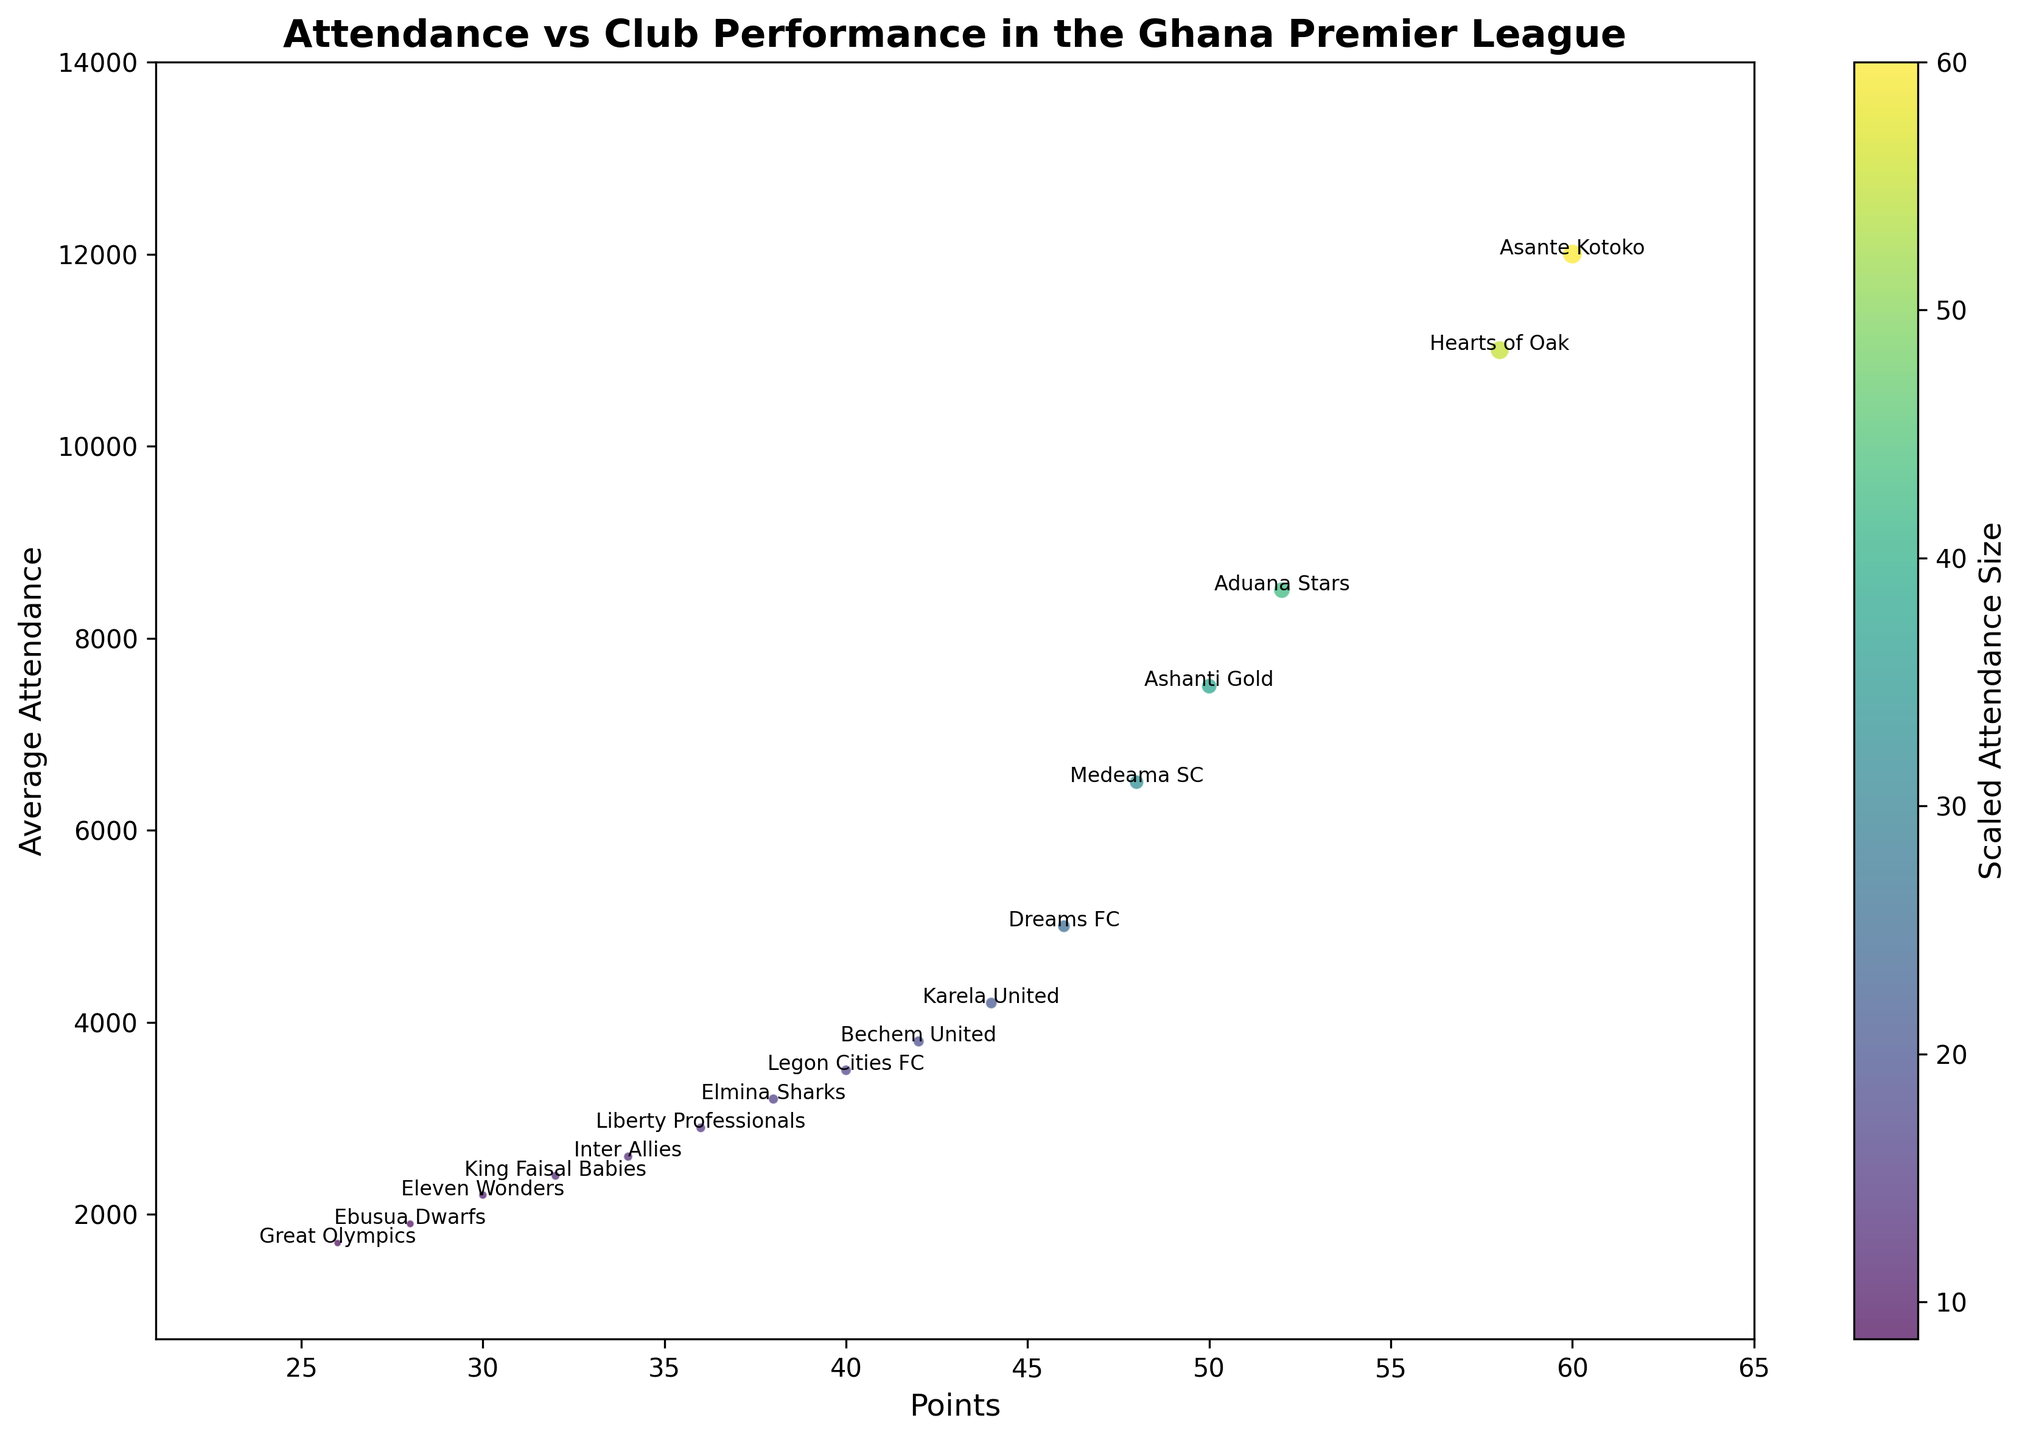What's the club with the highest attendance? The club with the highest attendance can be identified by checking the topmost point on the y-axis of the chart. The highest point corresponds to Asante Kotoko.
Answer: Asante Kotoko Which club has the lowest points? To find the club with the lowest points, look for the leftmost point on the x-axis of the chart. The leftmost point corresponds to Great Olympics.
Answer: Great Olympics How does the average attendance of Hearts of Oak compare to Aduana Stars? Look for the points labeled Hearts of Oak and Aduana Stars and compare their y-axis values. Hearts of Oak has an attendance of 11,000, which is higher than Aduana Stars' 8,500.
Answer: Hearts of Oak has higher attendance Which club has a higher performance, Medeama SC or Dreams FC? To compare performance, look at the x-axis values. Medeama SC has 48 points while Dreams FC has 46 points. This means Medeama SC has a higher performance.
Answer: Medeama SC What's the sum of attendance for Legon Cities FC and Inter Allies? Locate the attendance values for Legon Cities FC (3,500) and Inter Allies (2,600). Summing these values gives 3,500 + 2,600 = 6,100.
Answer: 6,100 Which club with an attendance over 10,000 has more points, Asante Kotoko or Hearts of Oak? Both clubs have an attendance over 10,000. Compare their points: Asante Kotoko has 60 points and Hearts of Oak has 58 points. Therefore, Asante Kotoko has more points.
Answer: Asante Kotoko What's the difference in points between Karela United and Bechem United? Check the x-axis values for Karela United (44) and Bechem United (42). The difference is 44 - 42 = 2 points.
Answer: 2 points Which club has the smallest bubble size on the chart? Bubble size is scaled by attendance. The smallest bubble will be for the club with the lowest attendance. Great Olympics, with an attendance of 1,700, is the smallest.
Answer: Great Olympics What's the combined attendance for the clubs with exactly 42 and 40 points? Bechem United has 42 points (3,800 attendance), and Legon Cities FC has 40 points (3,500 attendance). Adding these gives 3,800 + 3,500 = 7,300.
Answer: 7,300 